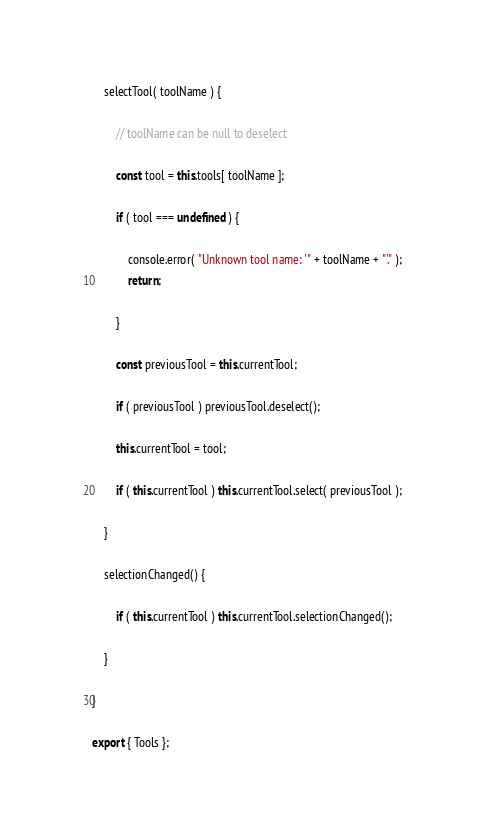<code> <loc_0><loc_0><loc_500><loc_500><_JavaScript_>
	selectTool( toolName ) {

		// toolName can be null to deselect

		const tool = this.tools[ toolName ];

		if ( tool === undefined ) {

			console.error( "Unknown tool name: '" + toolName + "'." );
			return;

		}

		const previousTool = this.currentTool;

		if ( previousTool ) previousTool.deselect();

		this.currentTool = tool;

		if ( this.currentTool ) this.currentTool.select( previousTool );

	}

	selectionChanged() {

		if ( this.currentTool ) this.currentTool.selectionChanged();
	}

}

export { Tools };</code> 